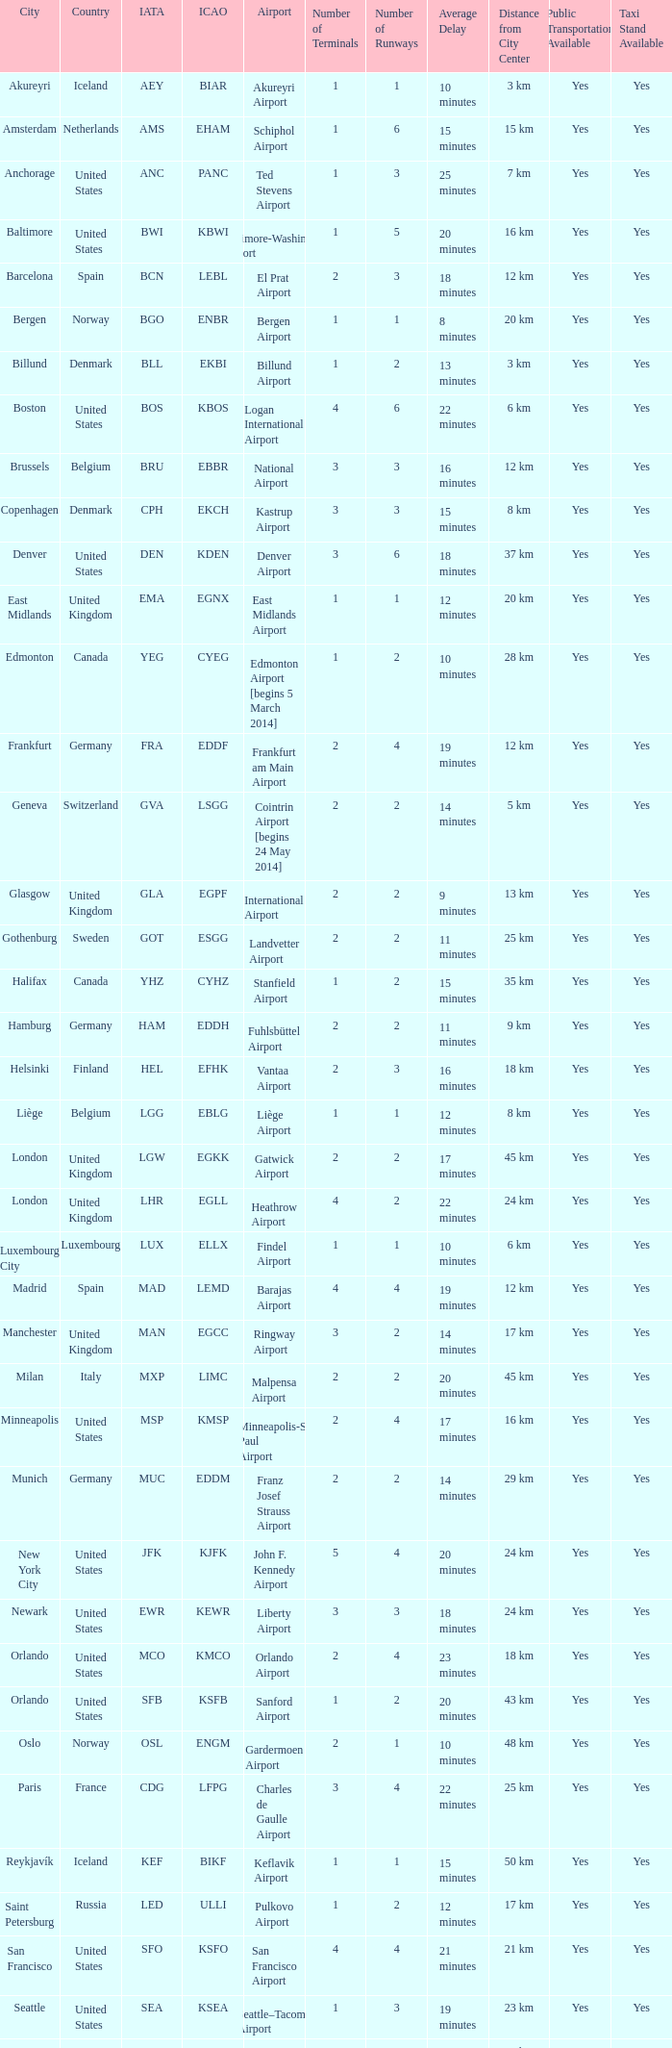What is the Airport with the ICAO fo KSEA? Seattle–Tacoma Airport. 